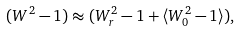Convert formula to latex. <formula><loc_0><loc_0><loc_500><loc_500>( W ^ { 2 } - 1 ) \approx ( W _ { r } ^ { 2 } - 1 + \langle W _ { 0 } ^ { 2 } - 1 \rangle ) ,</formula> 